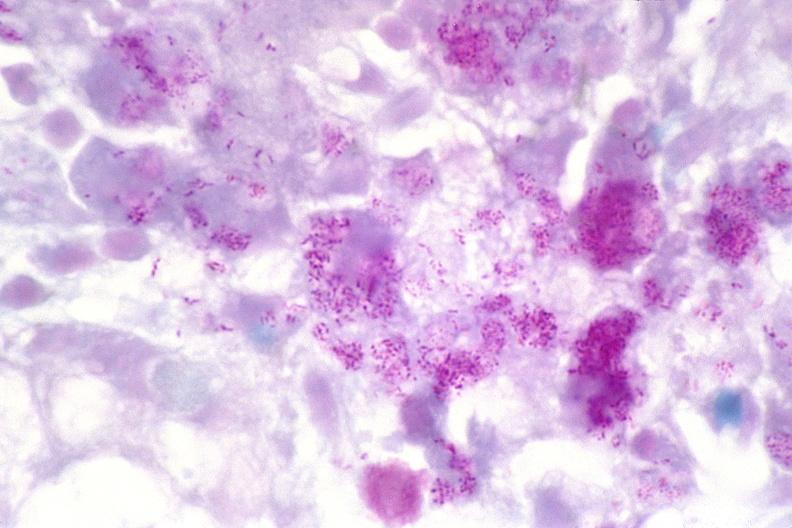do matting history of this case stain?
Answer the question using a single word or phrase. No 